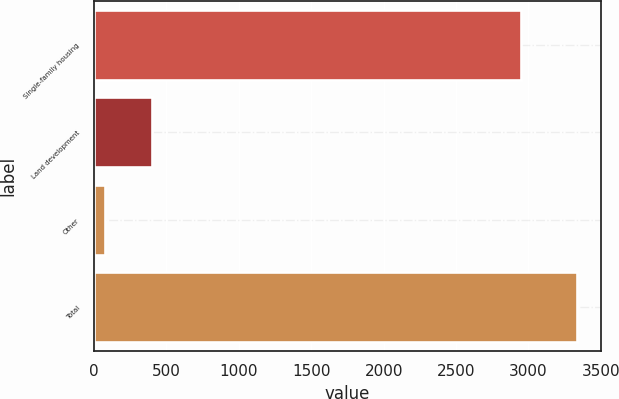<chart> <loc_0><loc_0><loc_500><loc_500><bar_chart><fcel>Single-family housing<fcel>Land development<fcel>Other<fcel>Total<nl><fcel>2951<fcel>400.1<fcel>74<fcel>3335<nl></chart> 